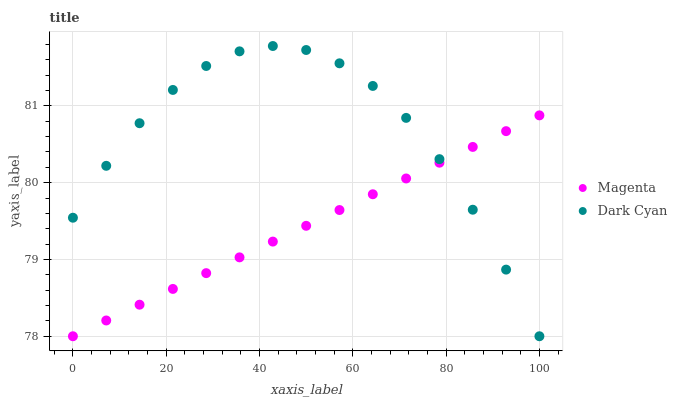Does Magenta have the minimum area under the curve?
Answer yes or no. Yes. Does Dark Cyan have the maximum area under the curve?
Answer yes or no. Yes. Does Magenta have the maximum area under the curve?
Answer yes or no. No. Is Magenta the smoothest?
Answer yes or no. Yes. Is Dark Cyan the roughest?
Answer yes or no. Yes. Is Magenta the roughest?
Answer yes or no. No. Does Dark Cyan have the lowest value?
Answer yes or no. Yes. Does Dark Cyan have the highest value?
Answer yes or no. Yes. Does Magenta have the highest value?
Answer yes or no. No. Does Magenta intersect Dark Cyan?
Answer yes or no. Yes. Is Magenta less than Dark Cyan?
Answer yes or no. No. Is Magenta greater than Dark Cyan?
Answer yes or no. No. 